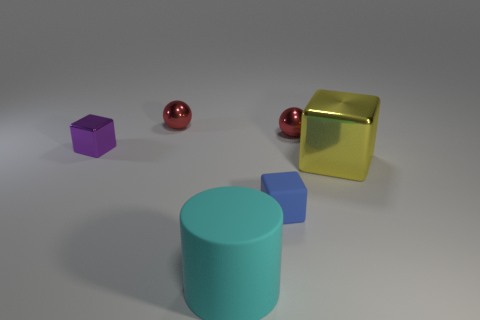Which objects in the image seem to share similar attributes, and what are these attributes? The two small spheres share similar attributes; they both have a glossy finish and a spherical shape. Their reflective surfaces suggest they are made of a material like polished metal. Do any of the objects form a pattern or have a common theme? The objects do not appear to form a conventional pattern, but they collectively represent a theme of geometric shapes, showcasing a variety of forms such as a cube, a sphere, and a cylinder. 